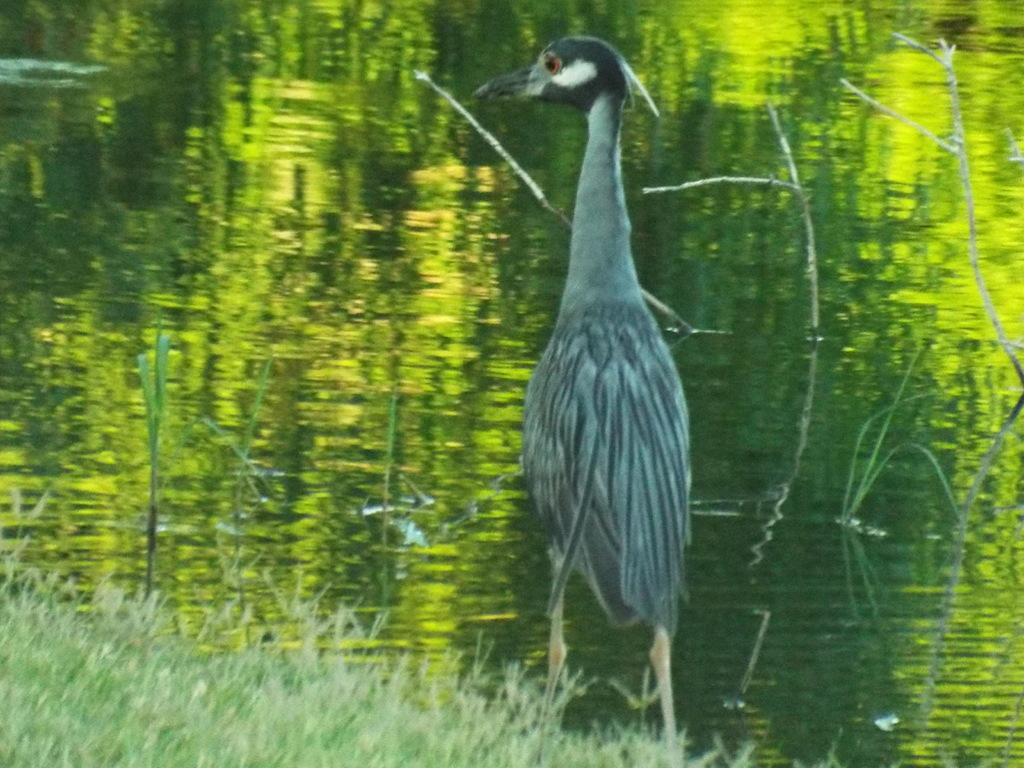What type of vegetation is present on the ground in the image? There is grass on the ground in the image. What animal can be seen in the center of the image? There is a bird standing in the center of the image. What can be seen in the distance in the image? There is water visible in the background of the image. What type of lamp is hanging from the tree in the image? There is no lamp present in the image; it features grass, a bird, and water in the background. What kind of stone is the bird sitting on in the image? There is no stone present in the image; the bird is standing on grass. 